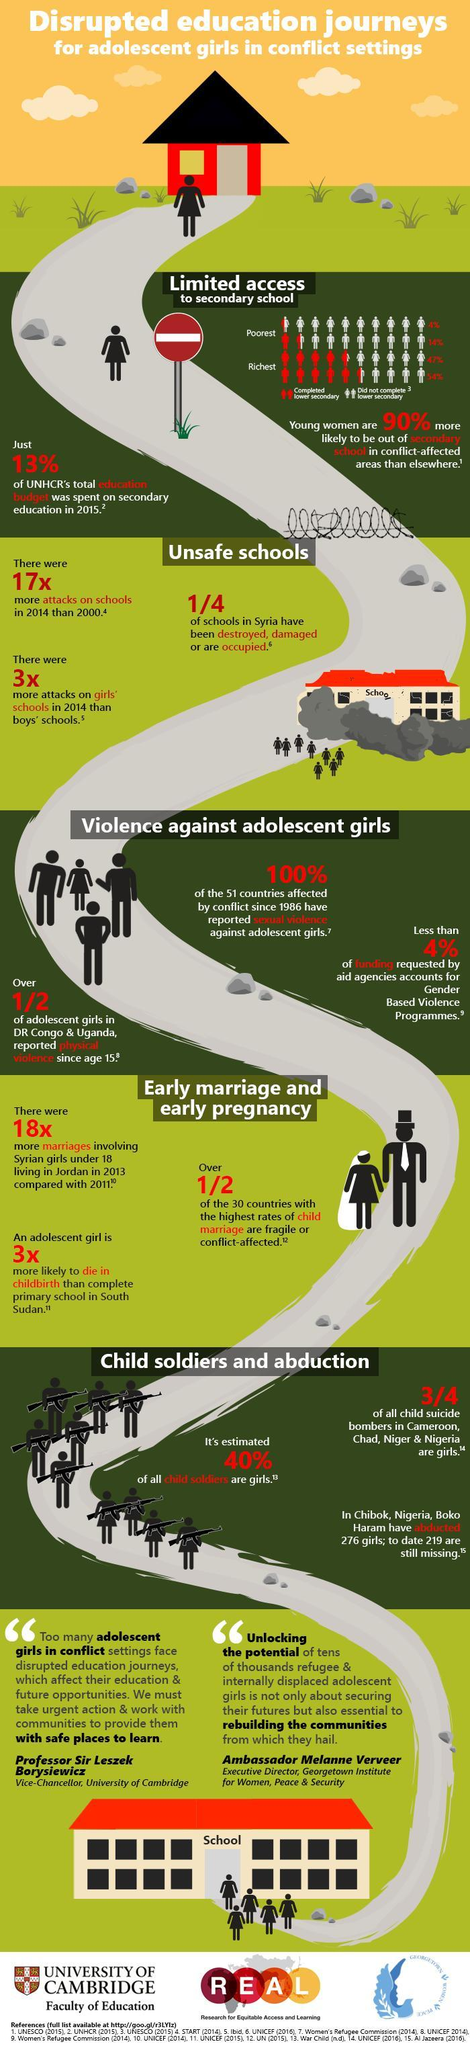What is the percentage of boys who were able to afford education, completed lower secondary school?
Answer the question with a short phrase. 54% What was the percentage of boys below poverty line were able to complete lower secondary school? 14% What is the percentage of girls who were able to afford education, completed lower secondary school? 47% What was the percentage of girls below poverty line were able to complete lower secondary school? 4% 